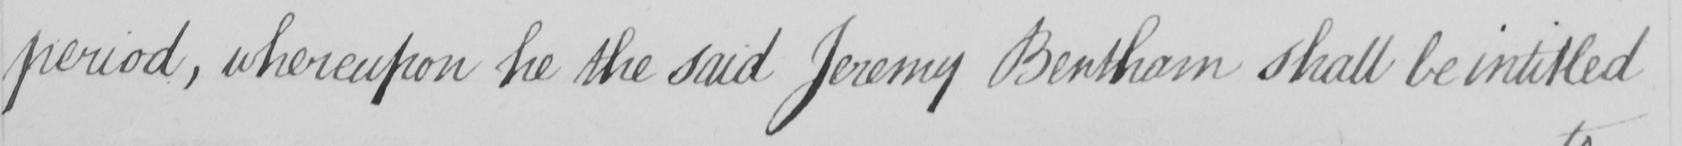Can you tell me what this handwritten text says? period , whereupon he the said Jeremy Bentham shall be intitled 